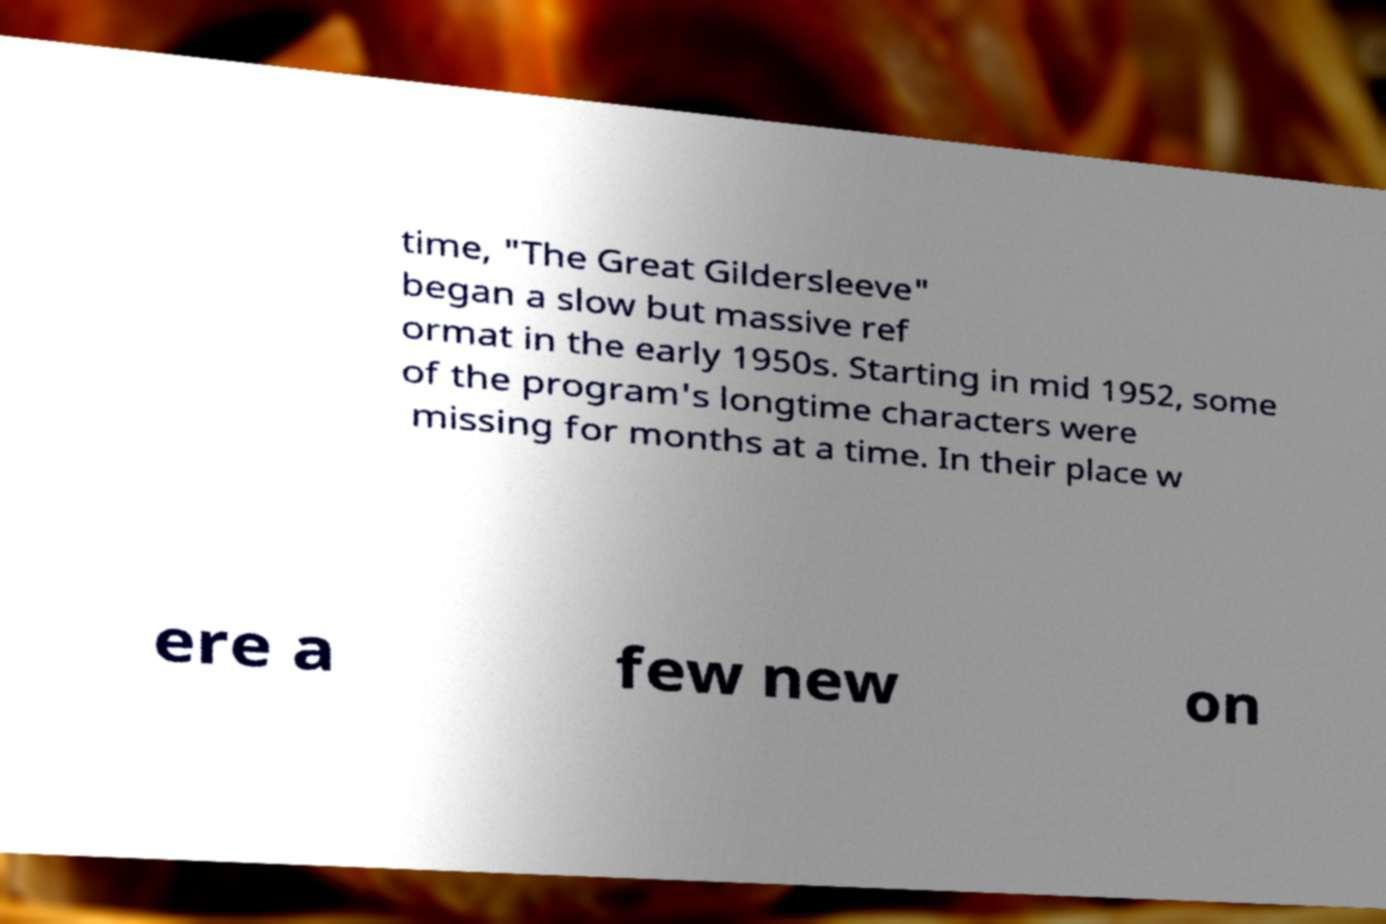Could you assist in decoding the text presented in this image and type it out clearly? time, "The Great Gildersleeve" began a slow but massive ref ormat in the early 1950s. Starting in mid 1952, some of the program's longtime characters were missing for months at a time. In their place w ere a few new on 